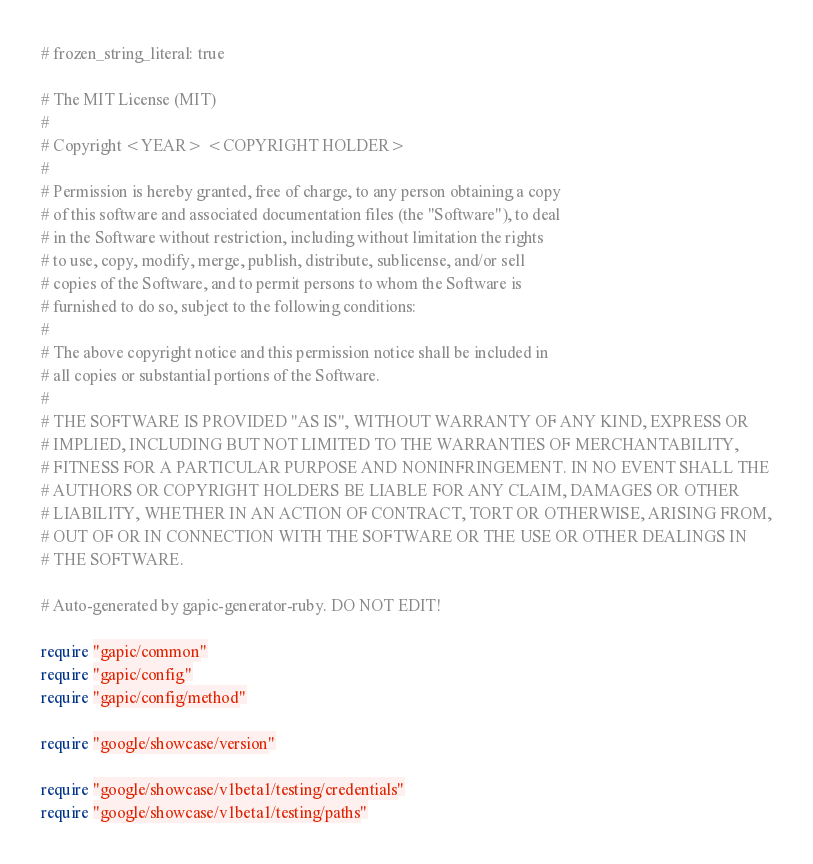<code> <loc_0><loc_0><loc_500><loc_500><_Ruby_># frozen_string_literal: true

# The MIT License (MIT)
#
# Copyright <YEAR> <COPYRIGHT HOLDER>
#
# Permission is hereby granted, free of charge, to any person obtaining a copy
# of this software and associated documentation files (the "Software"), to deal
# in the Software without restriction, including without limitation the rights
# to use, copy, modify, merge, publish, distribute, sublicense, and/or sell
# copies of the Software, and to permit persons to whom the Software is
# furnished to do so, subject to the following conditions:
#
# The above copyright notice and this permission notice shall be included in
# all copies or substantial portions of the Software.
#
# THE SOFTWARE IS PROVIDED "AS IS", WITHOUT WARRANTY OF ANY KIND, EXPRESS OR
# IMPLIED, INCLUDING BUT NOT LIMITED TO THE WARRANTIES OF MERCHANTABILITY,
# FITNESS FOR A PARTICULAR PURPOSE AND NONINFRINGEMENT. IN NO EVENT SHALL THE
# AUTHORS OR COPYRIGHT HOLDERS BE LIABLE FOR ANY CLAIM, DAMAGES OR OTHER
# LIABILITY, WHETHER IN AN ACTION OF CONTRACT, TORT OR OTHERWISE, ARISING FROM,
# OUT OF OR IN CONNECTION WITH THE SOFTWARE OR THE USE OR OTHER DEALINGS IN
# THE SOFTWARE.

# Auto-generated by gapic-generator-ruby. DO NOT EDIT!

require "gapic/common"
require "gapic/config"
require "gapic/config/method"

require "google/showcase/version"

require "google/showcase/v1beta1/testing/credentials"
require "google/showcase/v1beta1/testing/paths"</code> 